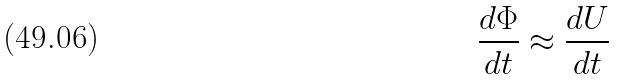Convert formula to latex. <formula><loc_0><loc_0><loc_500><loc_500>\frac { d \Phi } { d t } \approx \frac { d U } { d t }</formula> 